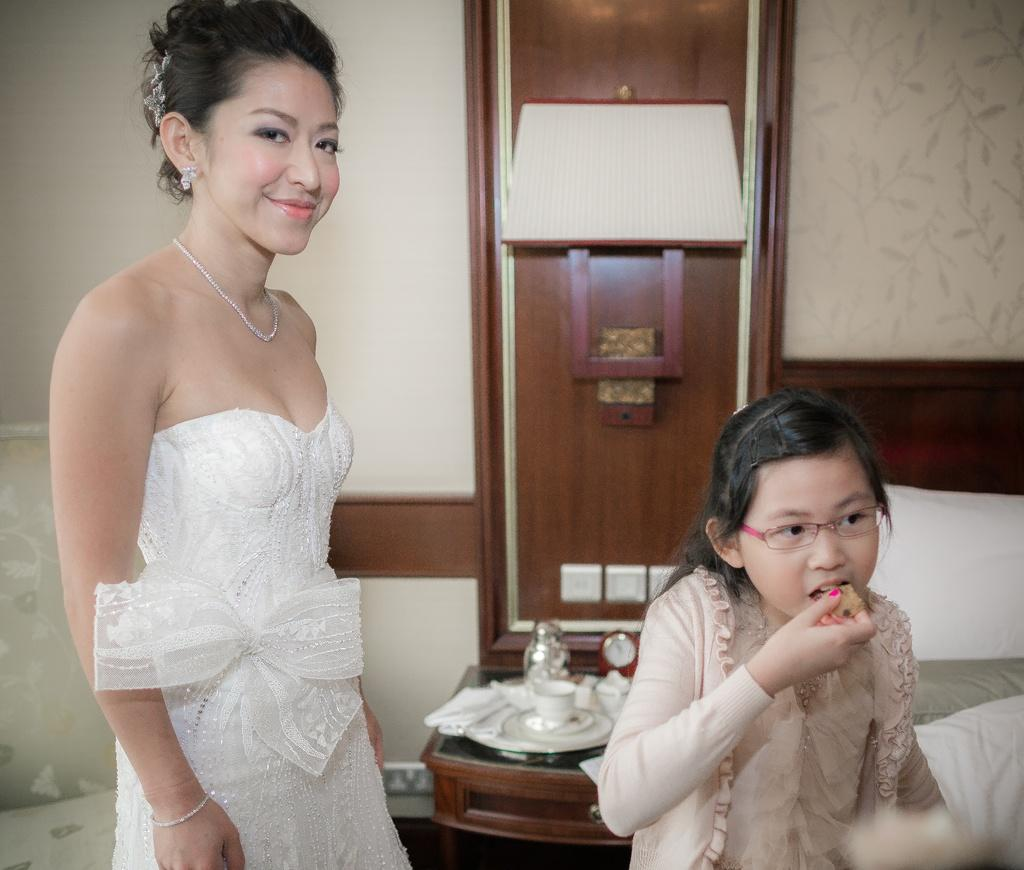What is the woman in the image wearing? The woman in the image is wearing a white dress. Who else is present in the image? There is a small girl in the image. What is the small girl doing? The small girl is eating cookies. What can be seen in the background of the image? There is a wall, a table, and a lamp in the background of the image. What type of cap is the woman wearing in the image? The woman in the image is not wearing a cap; she is wearing a white dress. What type of oil is being used to light the lamp in the image? There is no indication of the type of oil being used in the image, as the lamp is not shown to be lit. 